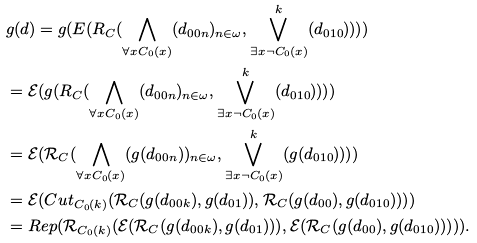<formula> <loc_0><loc_0><loc_500><loc_500>& g ( d ) = g ( E ( R _ { C } ( \bigwedge _ { \forall x C _ { 0 } ( x ) } ( d _ { 0 0 n } ) _ { n \in \omega } , \bigvee ^ { k } _ { \exists x \neg C _ { 0 } ( x ) } ( d _ { 0 1 0 } ) ) ) ) \\ & = \mathcal { E } ( g ( R _ { C } ( \bigwedge _ { \forall x C _ { 0 } ( x ) } ( d _ { 0 0 n } ) _ { n \in \omega } , \bigvee ^ { k } _ { \exists x \neg C _ { 0 } ( x ) } ( d _ { 0 1 0 } ) ) ) ) \\ & = \mathcal { E } ( \mathcal { R } _ { C } ( \bigwedge _ { \forall x C _ { 0 } ( x ) } ( g ( d _ { 0 0 n } ) ) _ { n \in \omega } , \bigvee ^ { k } _ { \exists x \neg C _ { 0 } ( x ) } ( g ( d _ { 0 1 0 } ) ) ) ) \\ & = \mathcal { E } ( C u t _ { C _ { 0 } ( k ) } ( \mathcal { R } _ { C } ( g ( d _ { 0 0 k } ) , g ( d _ { 0 1 } ) ) , \mathcal { R } _ { C } ( g ( d _ { 0 0 } ) , g ( d _ { 0 1 0 } ) ) ) ) \\ & = R e p ( \mathcal { R } _ { C _ { 0 } ( k ) } ( \mathcal { E } ( \mathcal { R } _ { C } ( g ( d _ { 0 0 k } ) , g ( d _ { 0 1 } ) ) ) , \mathcal { E } ( \mathcal { R } _ { C } ( g ( d _ { 0 0 } ) , g ( d _ { 0 1 0 } ) ) ) ) ) . \\</formula> 